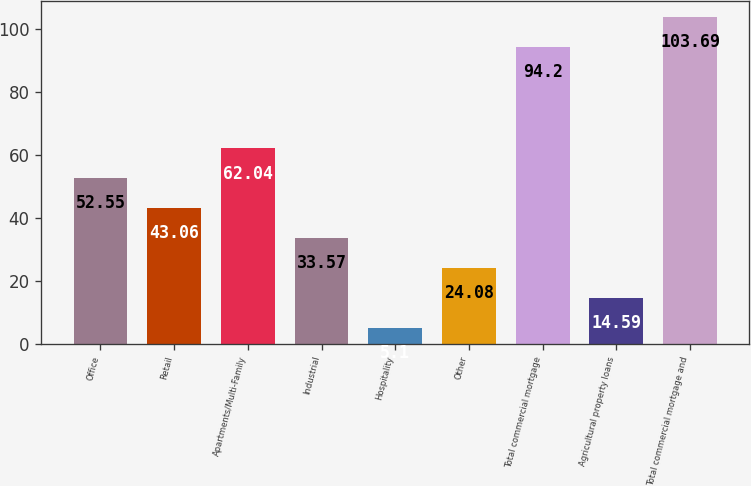Convert chart. <chart><loc_0><loc_0><loc_500><loc_500><bar_chart><fcel>Office<fcel>Retail<fcel>Apartments/Multi-Family<fcel>Industrial<fcel>Hospitality<fcel>Other<fcel>Total commercial mortgage<fcel>Agricultural property loans<fcel>Total commercial mortgage and<nl><fcel>52.55<fcel>43.06<fcel>62.04<fcel>33.57<fcel>5.1<fcel>24.08<fcel>94.2<fcel>14.59<fcel>103.69<nl></chart> 